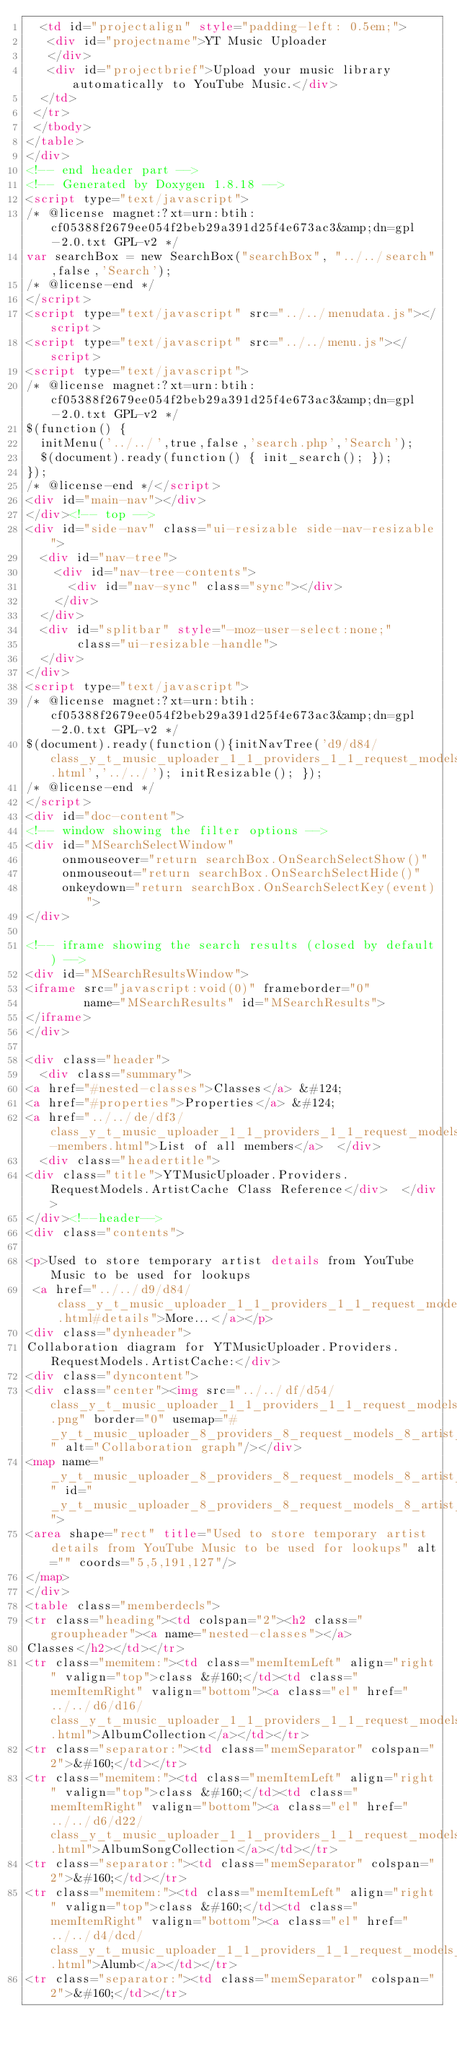Convert code to text. <code><loc_0><loc_0><loc_500><loc_500><_HTML_>  <td id="projectalign" style="padding-left: 0.5em;">
   <div id="projectname">YT Music Uploader
   </div>
   <div id="projectbrief">Upload your music library automatically to YouTube Music.</div>
  </td>
 </tr>
 </tbody>
</table>
</div>
<!-- end header part -->
<!-- Generated by Doxygen 1.8.18 -->
<script type="text/javascript">
/* @license magnet:?xt=urn:btih:cf05388f2679ee054f2beb29a391d25f4e673ac3&amp;dn=gpl-2.0.txt GPL-v2 */
var searchBox = new SearchBox("searchBox", "../../search",false,'Search');
/* @license-end */
</script>
<script type="text/javascript" src="../../menudata.js"></script>
<script type="text/javascript" src="../../menu.js"></script>
<script type="text/javascript">
/* @license magnet:?xt=urn:btih:cf05388f2679ee054f2beb29a391d25f4e673ac3&amp;dn=gpl-2.0.txt GPL-v2 */
$(function() {
  initMenu('../../',true,false,'search.php','Search');
  $(document).ready(function() { init_search(); });
});
/* @license-end */</script>
<div id="main-nav"></div>
</div><!-- top -->
<div id="side-nav" class="ui-resizable side-nav-resizable">
  <div id="nav-tree">
    <div id="nav-tree-contents">
      <div id="nav-sync" class="sync"></div>
    </div>
  </div>
  <div id="splitbar" style="-moz-user-select:none;" 
       class="ui-resizable-handle">
  </div>
</div>
<script type="text/javascript">
/* @license magnet:?xt=urn:btih:cf05388f2679ee054f2beb29a391d25f4e673ac3&amp;dn=gpl-2.0.txt GPL-v2 */
$(document).ready(function(){initNavTree('d9/d84/class_y_t_music_uploader_1_1_providers_1_1_request_models_1_1_artist_cache.html','../../'); initResizable(); });
/* @license-end */
</script>
<div id="doc-content">
<!-- window showing the filter options -->
<div id="MSearchSelectWindow"
     onmouseover="return searchBox.OnSearchSelectShow()"
     onmouseout="return searchBox.OnSearchSelectHide()"
     onkeydown="return searchBox.OnSearchSelectKey(event)">
</div>

<!-- iframe showing the search results (closed by default) -->
<div id="MSearchResultsWindow">
<iframe src="javascript:void(0)" frameborder="0" 
        name="MSearchResults" id="MSearchResults">
</iframe>
</div>

<div class="header">
  <div class="summary">
<a href="#nested-classes">Classes</a> &#124;
<a href="#properties">Properties</a> &#124;
<a href="../../de/df3/class_y_t_music_uploader_1_1_providers_1_1_request_models_1_1_artist_cache-members.html">List of all members</a>  </div>
  <div class="headertitle">
<div class="title">YTMusicUploader.Providers.RequestModels.ArtistCache Class Reference</div>  </div>
</div><!--header-->
<div class="contents">

<p>Used to store temporary artist details from YouTube Music to be used for lookups  
 <a href="../../d9/d84/class_y_t_music_uploader_1_1_providers_1_1_request_models_1_1_artist_cache.html#details">More...</a></p>
<div class="dynheader">
Collaboration diagram for YTMusicUploader.Providers.RequestModels.ArtistCache:</div>
<div class="dyncontent">
<div class="center"><img src="../../df/d54/class_y_t_music_uploader_1_1_providers_1_1_request_models_1_1_artist_cache__coll__graph.png" border="0" usemap="#_y_t_music_uploader_8_providers_8_request_models_8_artist_cache_coll__map" alt="Collaboration graph"/></div>
<map name="_y_t_music_uploader_8_providers_8_request_models_8_artist_cache_coll__map" id="_y_t_music_uploader_8_providers_8_request_models_8_artist_cache_coll__map">
<area shape="rect" title="Used to store temporary artist details from YouTube Music to be used for lookups" alt="" coords="5,5,191,127"/>
</map>
</div>
<table class="memberdecls">
<tr class="heading"><td colspan="2"><h2 class="groupheader"><a name="nested-classes"></a>
Classes</h2></td></tr>
<tr class="memitem:"><td class="memItemLeft" align="right" valign="top">class &#160;</td><td class="memItemRight" valign="bottom"><a class="el" href="../../d6/d16/class_y_t_music_uploader_1_1_providers_1_1_request_models_1_1_artist_cache_1_1_album_collection.html">AlbumCollection</a></td></tr>
<tr class="separator:"><td class="memSeparator" colspan="2">&#160;</td></tr>
<tr class="memitem:"><td class="memItemLeft" align="right" valign="top">class &#160;</td><td class="memItemRight" valign="bottom"><a class="el" href="../../d6/d22/class_y_t_music_uploader_1_1_providers_1_1_request_models_1_1_artist_cache_1_1_album_song_collection.html">AlbumSongCollection</a></td></tr>
<tr class="separator:"><td class="memSeparator" colspan="2">&#160;</td></tr>
<tr class="memitem:"><td class="memItemLeft" align="right" valign="top">class &#160;</td><td class="memItemRight" valign="bottom"><a class="el" href="../../d4/dcd/class_y_t_music_uploader_1_1_providers_1_1_request_models_1_1_artist_cache_1_1_alumb.html">Alumb</a></td></tr>
<tr class="separator:"><td class="memSeparator" colspan="2">&#160;</td></tr></code> 